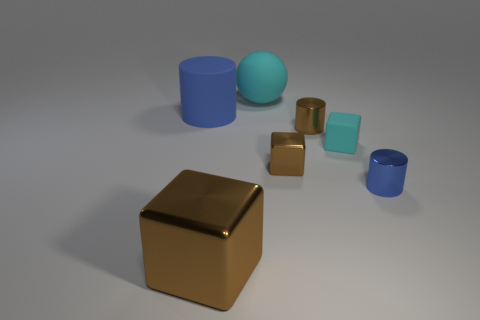There is a object that is on the left side of the large sphere and in front of the big rubber cylinder; what color is it?
Give a very brief answer. Brown. What number of big green rubber objects are there?
Offer a very short reply. 0. Does the cyan sphere have the same size as the blue metal cylinder?
Ensure brevity in your answer.  No. Are there any other metallic cubes that have the same color as the big metal block?
Your response must be concise. Yes. Does the tiny blue object right of the large brown object have the same shape as the big brown shiny thing?
Provide a short and direct response. No. How many brown shiny cubes are the same size as the sphere?
Provide a short and direct response. 1. There is a metal cylinder that is in front of the tiny cyan cube; how many big brown metallic cubes are behind it?
Your answer should be very brief. 0. Is the large thing to the left of the large brown cube made of the same material as the large cyan thing?
Keep it short and to the point. Yes. Are the blue cylinder behind the tiny rubber cube and the brown cube that is in front of the tiny blue metal object made of the same material?
Offer a very short reply. No. Are there more shiny things behind the blue metal cylinder than rubber cylinders?
Offer a terse response. Yes. 